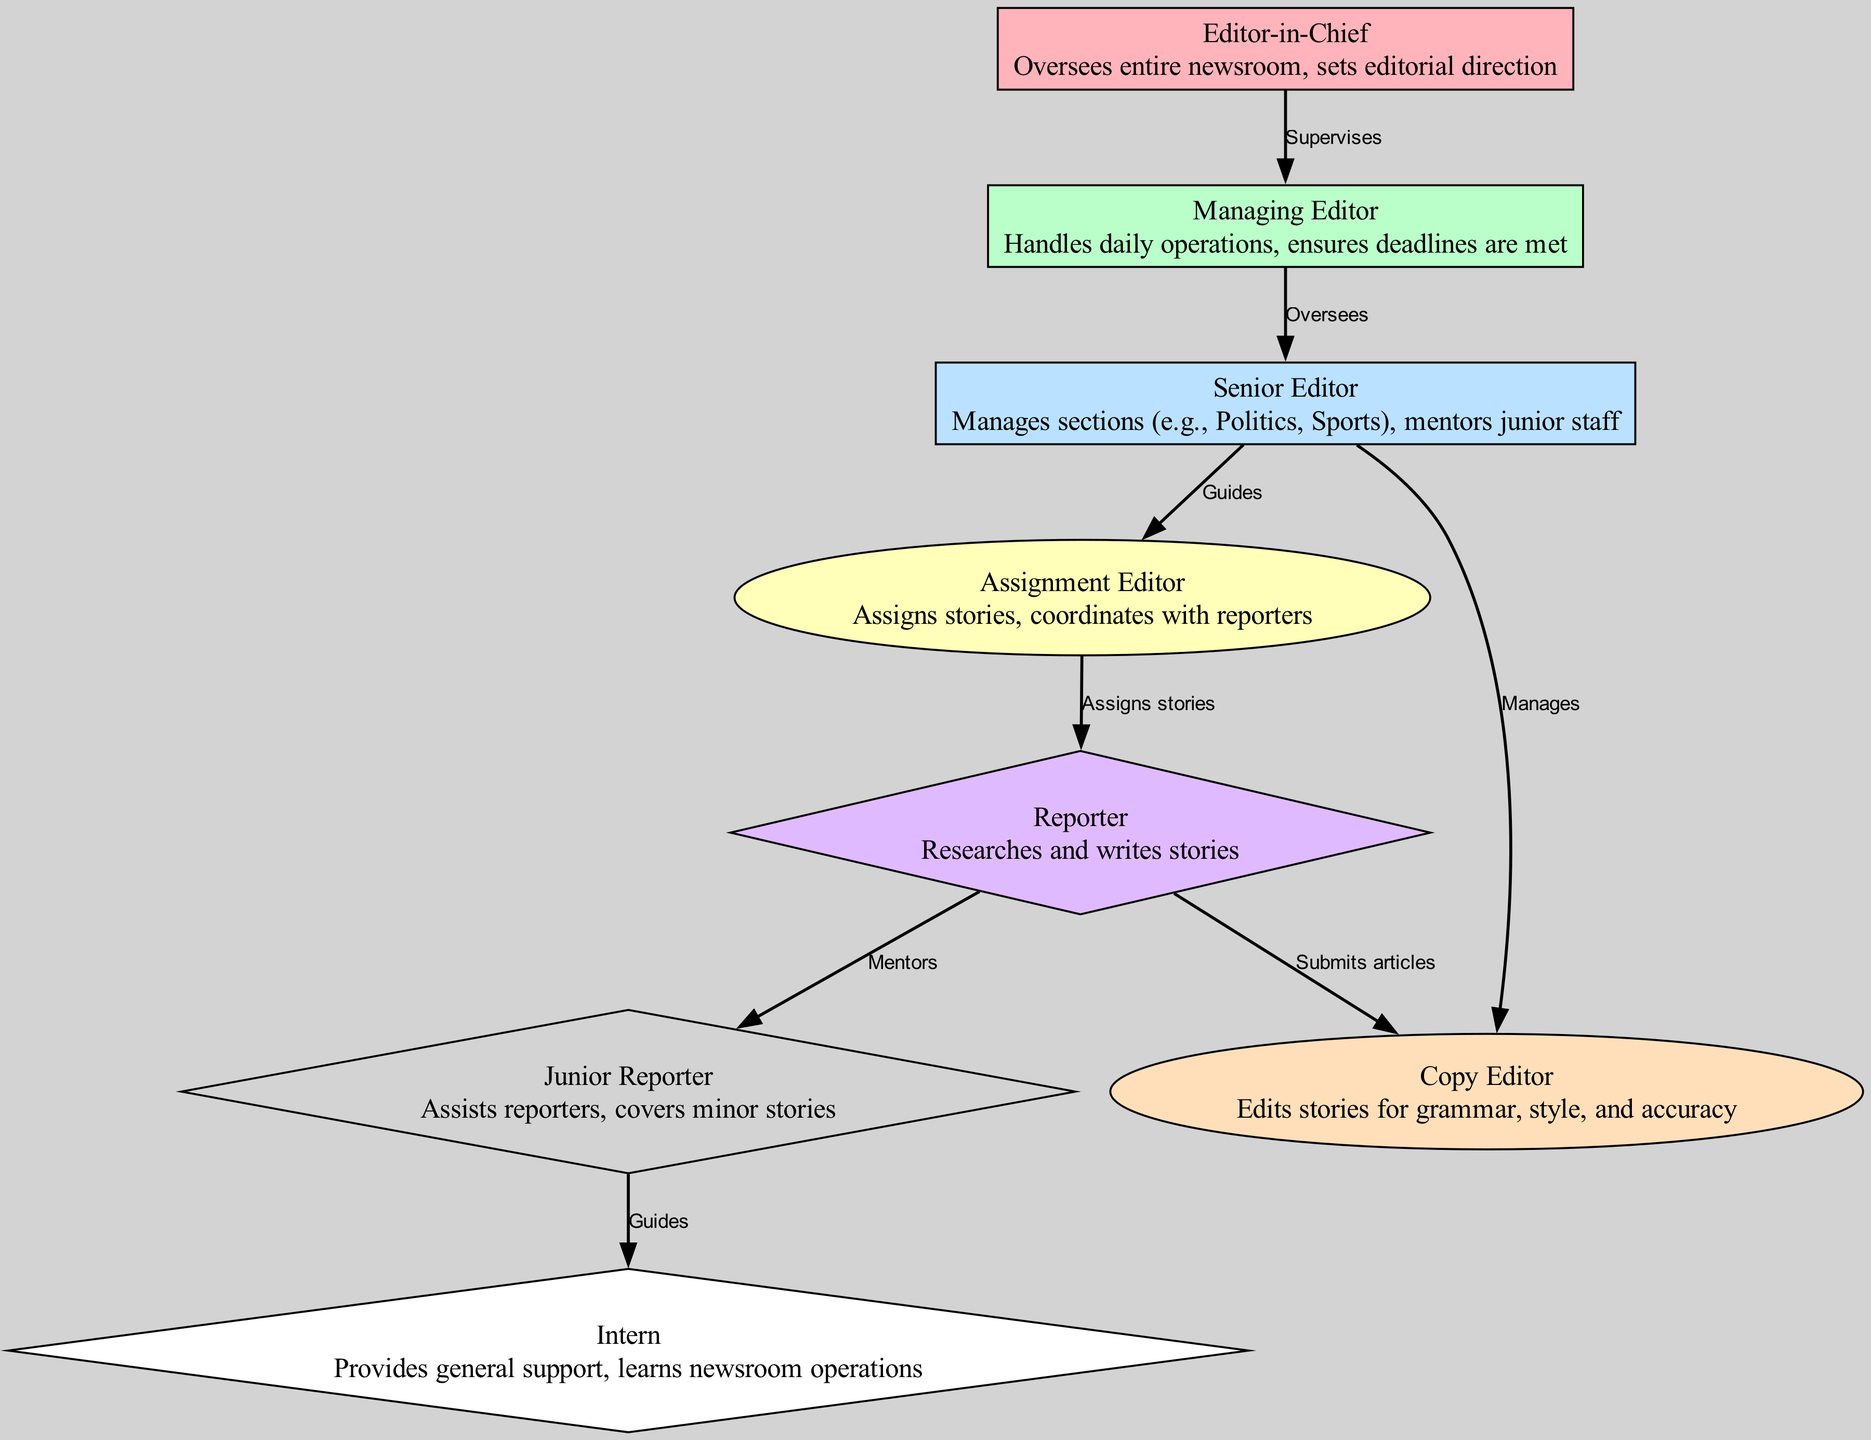What is the highest position in the organizational hierarchy? The diagram shows that "Editor-in-Chief" is at the top of the hierarchy, signifying the highest position in the newsroom structure.
Answer: Editor-in-Chief How many specific roles are illustrated in the diagram? By counting the nodes represented in the diagram, we find that there are eight distinct roles listed.
Answer: Eight Which role supervises the Managing Editor? Trace the directed edge leading from the "Editor-in-Chief" to "Managing Editor," indicating that the Editor-in-Chief supervises this position.
Answer: Editor-in-Chief What is the role of the Copy Editor? The diagram labels the Copy Editor's role as "Edits stories for grammar, style, and accuracy," defining their responsibilities in the newsroom.
Answer: Edits stories for grammar, style, and accuracy Who does the Senior Editor guide? The flowchart indicates that the "Senior Editor" guides the "Assignment Editor," showing a direct supervisory relationship.
Answer: Assignment Editor What type of relationship exists between the Junior Reporter and the Intern? The diagram illustrates that the Junior Reporter guides the Intern, indicating a mentoring relationship rather than supervision.
Answer: Guides Which role is responsible for overseeing the daily operations? The diagram specifies that the "Managing Editor" is responsible for handling daily operations, as clearly stated in its explanation.
Answer: Managing Editor How many reporting roles are shown in the diagram? Upon examining the roles, we see that there are three distinct reporting roles: Reporter, Junior Reporter, and Intern, which support the newsroom's reporting structure.
Answer: Three Which role submits articles to the Copy Editor? The "Reporter" is represented as the role that submits articles to the Copy Editor, confirming the flow of story production and editing.
Answer: Reporter 